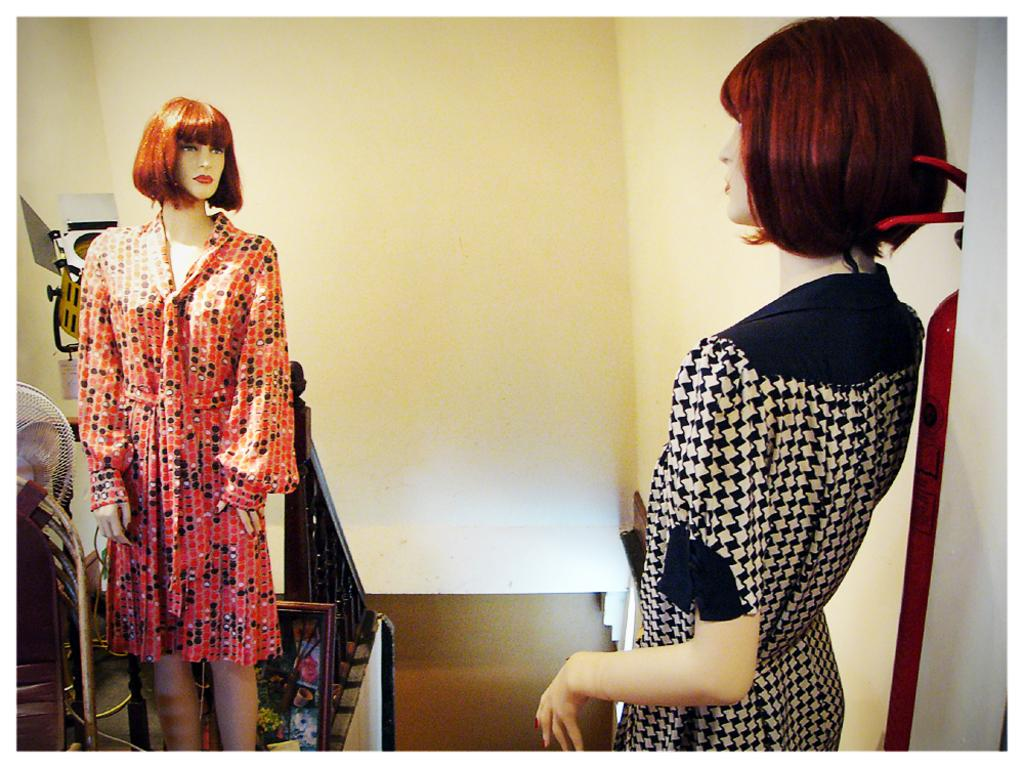How many mannequins are in the image? There are two mannequins in the image. What are the mannequins wearing? Both mannequins are wearing dresses. What can be seen on the left side of the image? There is a fan, railings, a frame, and other unspecified objects on the left side of the image. How many matches are being used by the mannequins in the image? There are no matches present in the image, as it features mannequins wearing dresses and various objects on the left side. 